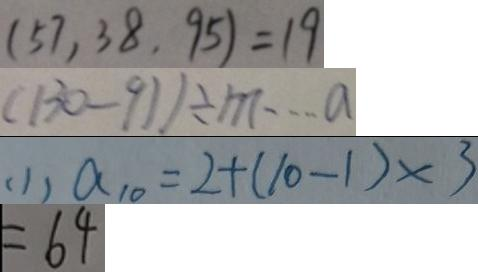Convert formula to latex. <formula><loc_0><loc_0><loc_500><loc_500>( 5 7 , 3 8 , 9 5 ) = 1 9 
 ( 1 3 0 - 9 1 ) \div m \cdots a 
 ( 1 ) a _ { 1 0 } = 2 + ( 1 0 - 1 ) \times 3 
 = 6 4</formula> 